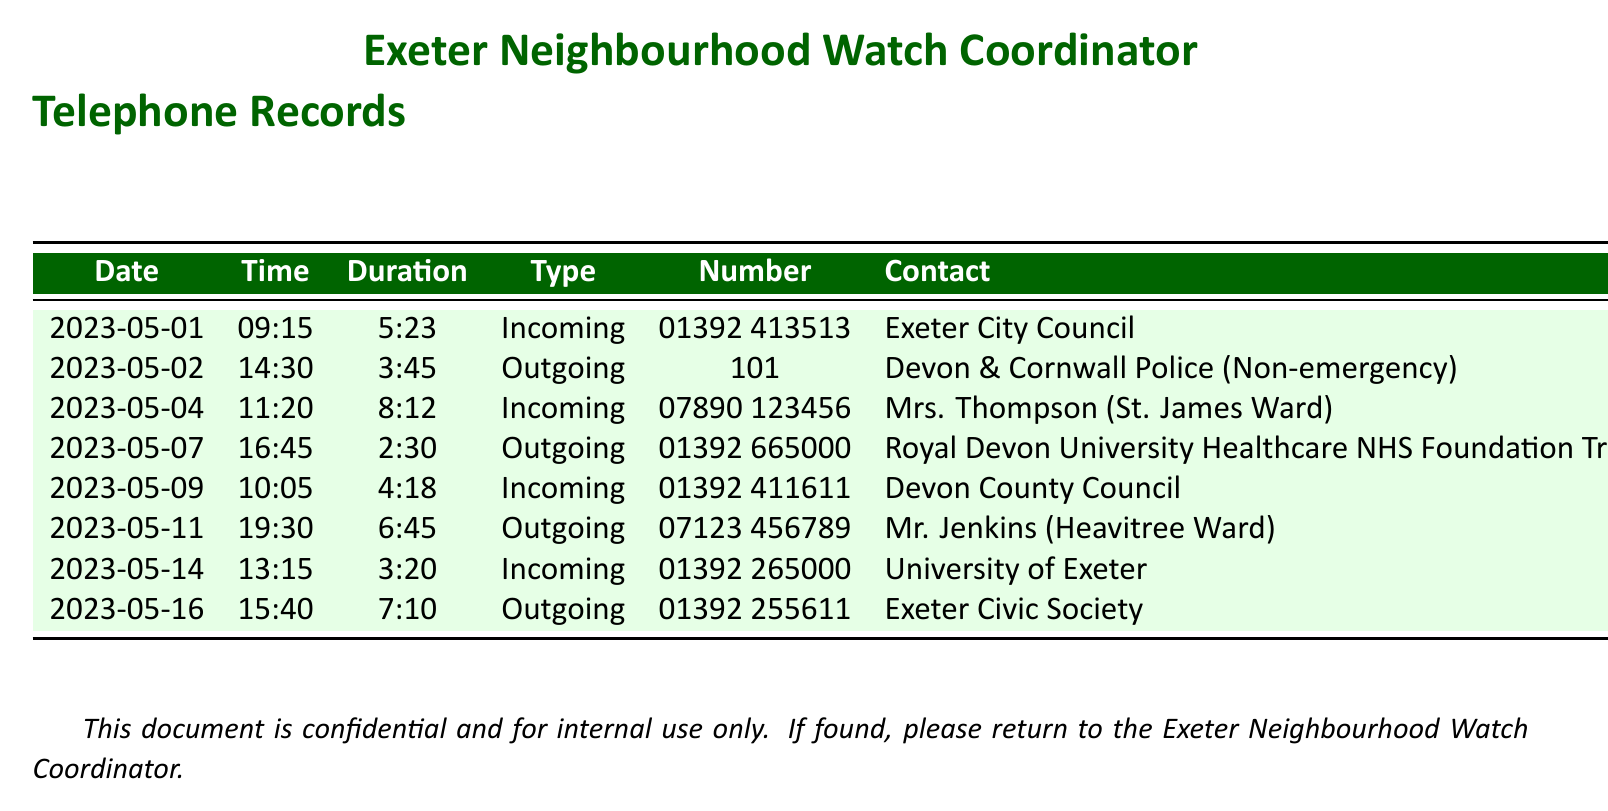what is the date of the first incoming call? The first incoming call is recorded on May 1st, 2023.
Answer: 2023-05-01 who is the contact for the outgoing call on May 2nd? The contact for the outgoing call on May 2nd is Devon & Cornwall Police (Non-emergency).
Answer: Devon & Cornwall Police (Non-emergency) how long was the call with Exeter City Council? The duration of the call with Exeter City Council is recorded as 5 minutes and 23 seconds.
Answer: 5:23 which ward does Mrs. Thompson represent? The document indicates that Mrs. Thompson is from St. James Ward.
Answer: St. James Ward how many outgoing calls were made in total? Counting the entries, there are four outgoing calls listed in the document.
Answer: 4 who called the Neighbourhood Watch coordinator on May 9th? The incoming call on May 9th was from Devon County Council.
Answer: Devon County Council what time was the call with Mr. Jenkins? The call with Mr. Jenkins took place at 19:30.
Answer: 19:30 which organization is listed as the contact for the call on May 14th? The organization listed for the call on May 14th is the University of Exeter.
Answer: University of Exeter 